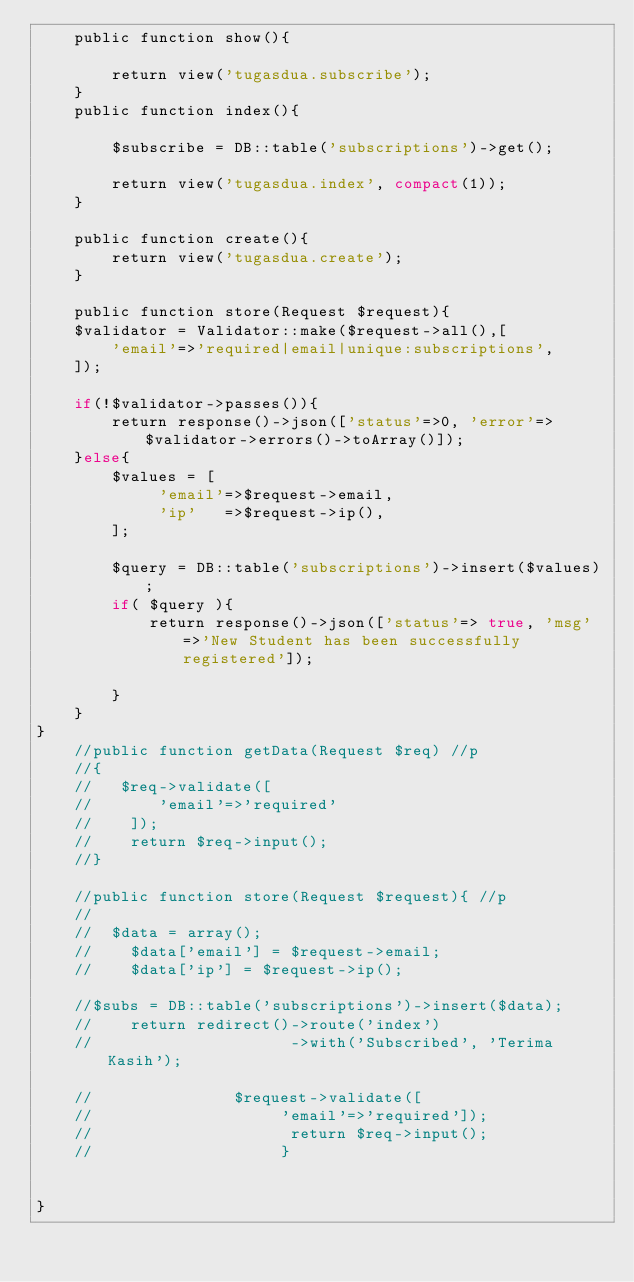<code> <loc_0><loc_0><loc_500><loc_500><_PHP_>    public function show(){

        return view('tugasdua.subscribe');
    }
    public function index(){

        $subscribe = DB::table('subscriptions')->get();

        return view('tugasdua.index', compact(1));
    }

    public function create(){
        return view('tugasdua.create');
    }

    public function store(Request $request){
    $validator = Validator::make($request->all(),[        
        'email'=>'required|email|unique:subscriptions',
    ]);

    if(!$validator->passes()){
        return response()->json(['status'=>0, 'error'=>$validator->errors()->toArray()]);
    }else{
        $values = [
             'email'=>$request->email,
             'ip'   =>$request->ip(),
        ];

        $query = DB::table('subscriptions')->insert($values);
        if( $query ){
            return response()->json(['status'=> true, 'msg'=>'New Student has been successfully registered']);
                        
        }                       
    }
}
    //public function getData(Request $req) //p
    //{
    //   $req->validate([
    //       'email'=>'required'
    //    ]);
    //    return $req->input();
    //}

    //public function store(Request $request){ //p
    //
    //  $data = array();
    //    $data['email'] = $request->email;
    //    $data['ip'] = $request->ip();
    
    //$subs = DB::table('subscriptions')->insert($data);
    //    return redirect()->route('index')
    //                     ->with('Subscribed', 'Terima Kasih');

    //               $request->validate([
    //                    'email'=>'required']);
    //                     return $req->input();
    //                    }

    
}
</code> 